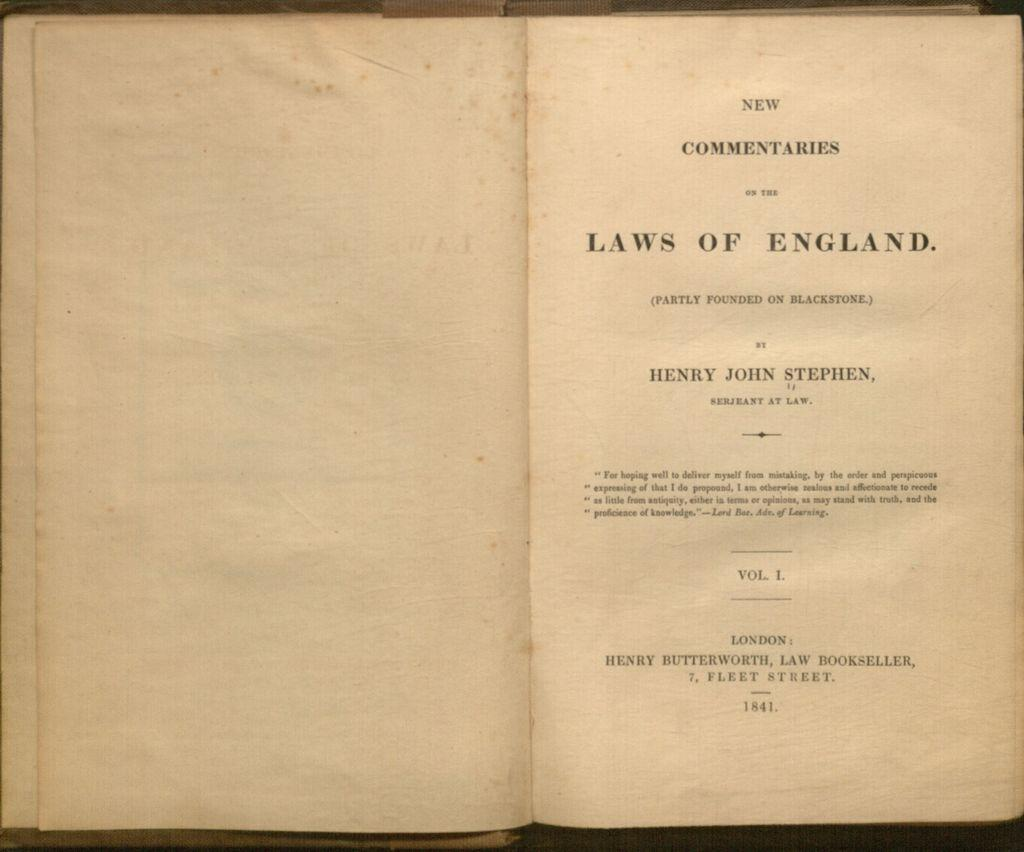<image>
Relay a brief, clear account of the picture shown. an old book open to the title page called Laws of England 